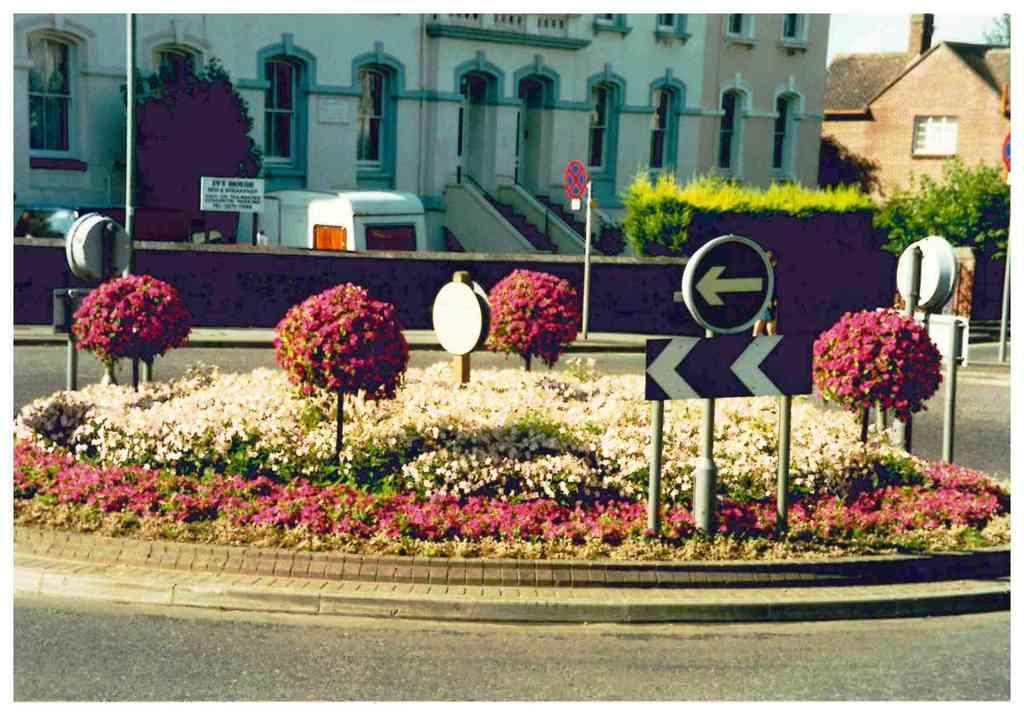What is the main object in the image? There is a signboard in the image. What type of vegetation is present in the image? There are plants with flowers in the image. What can be seen in the background of the image? There are buildings and trees in the background of the image. What features do the buildings have? The buildings have windows and signboards. How many rings does the carpenter wear on his fingers in the image? There is no carpenter or rings present in the image. What type of calculator is being used by the person in the image? There is no calculator or person present in the image. 